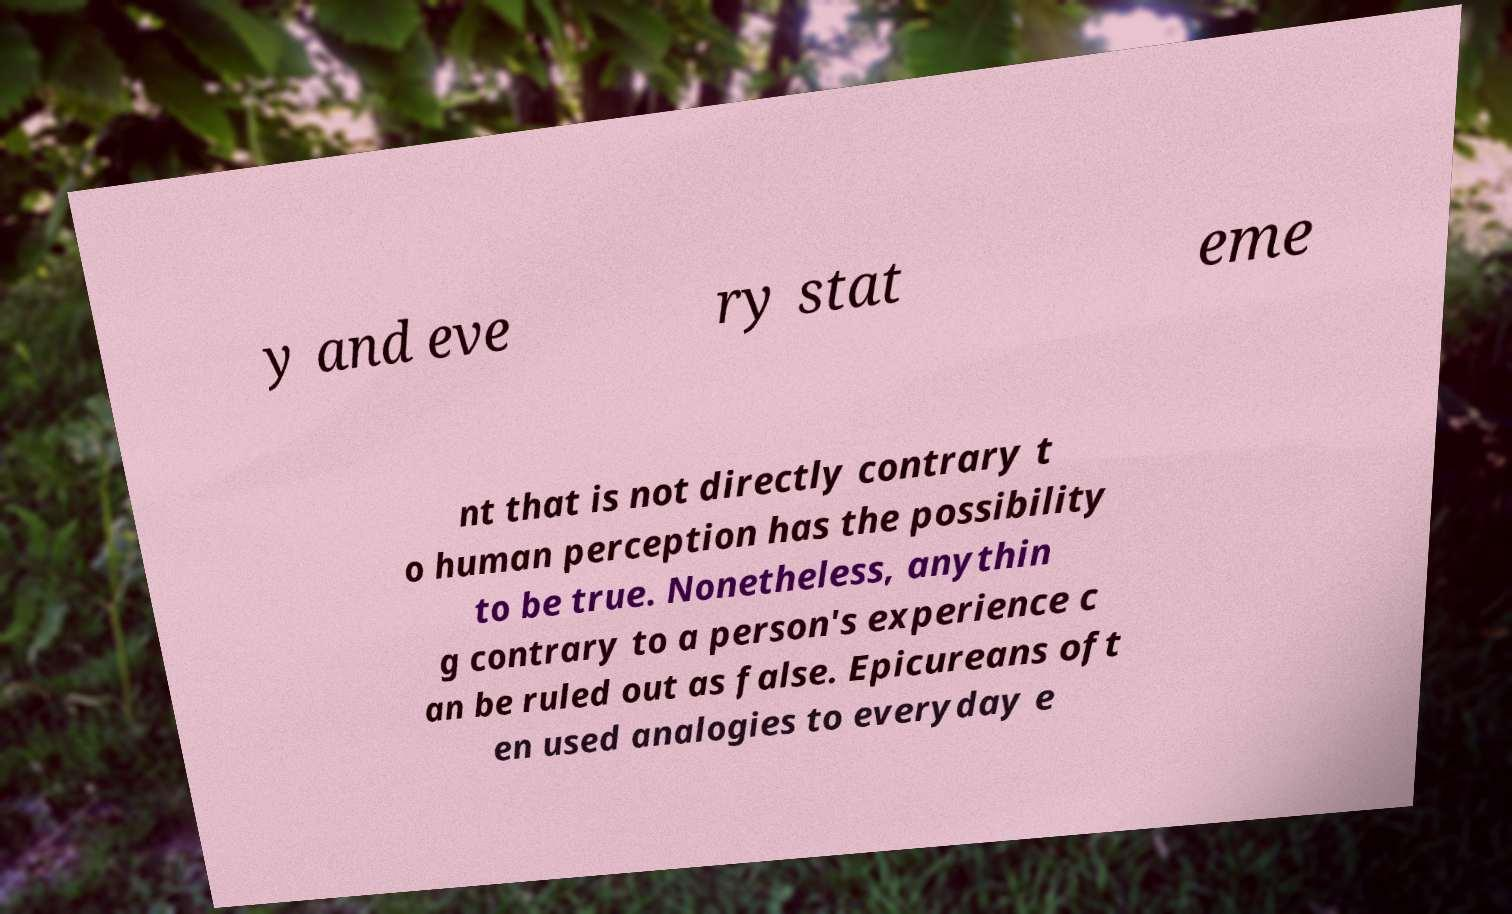For documentation purposes, I need the text within this image transcribed. Could you provide that? y and eve ry stat eme nt that is not directly contrary t o human perception has the possibility to be true. Nonetheless, anythin g contrary to a person's experience c an be ruled out as false. Epicureans oft en used analogies to everyday e 